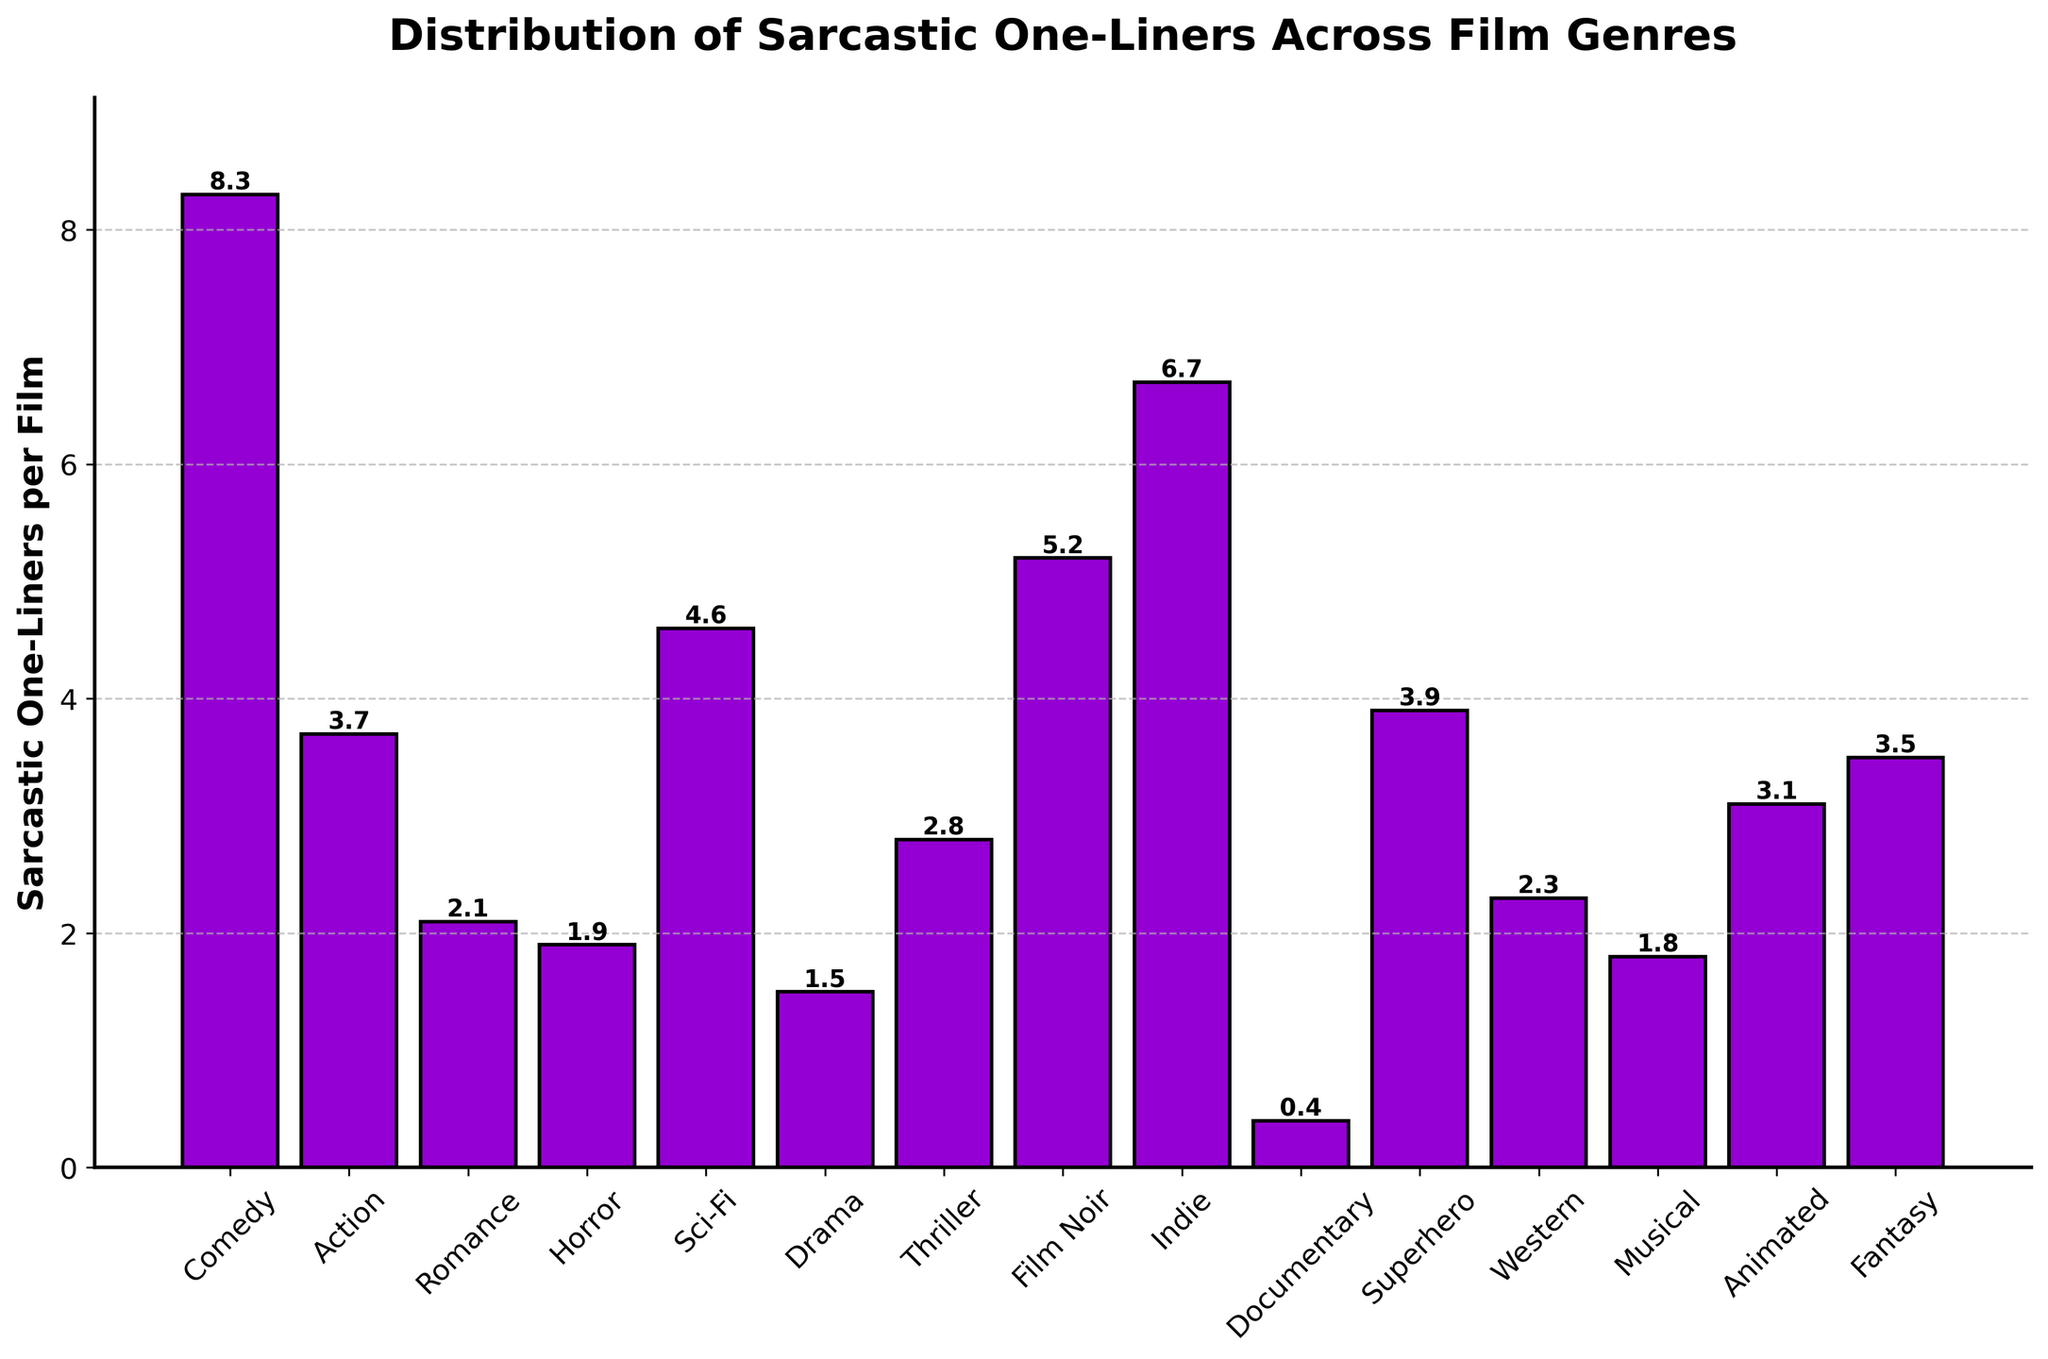What genre has the highest number of sarcastic one-liners per film? From the bar chart, the genre with the tallest bar represents the highest number of sarcastic one-liners per film. The bar for Comedy is the highest at 8.3.
Answer: Comedy Which genres have a higher number of sarcastic one-liners per film than Action? By comparing the height of the bars, genres with higher bars than Action (3.7) are Comedy, Sci-Fi, Film Noir, Indie, and Superhero.
Answer: Comedy, Sci-Fi, Film Noir, Indie, Superhero What is the combined average number of sarcastic one-liners per film for Romance and Horror? The number of sarcastic one-liners for Romance is 2.1 and for Horror is 1.9. Their combined average is (2.1 + 1.9) / 2 = 2.0.
Answer: 2.0 How many genres have fewer than 3 sarcastic one-liners per film? Looking at the bars, the genres with fewer than 3 sarcastic one-liners are Romance, Horror, Drama, Documentary, Musical, and Western; thus totaling 6 genres.
Answer: 6 Which genre has the smallest number of sarcastic one-liners per film, and what is its value? The shortest bar represents the smallest number of sarcastic one-liners per film. The Documentary genre has the shortest bar at 0.4.
Answer: Documentary, 0.4 